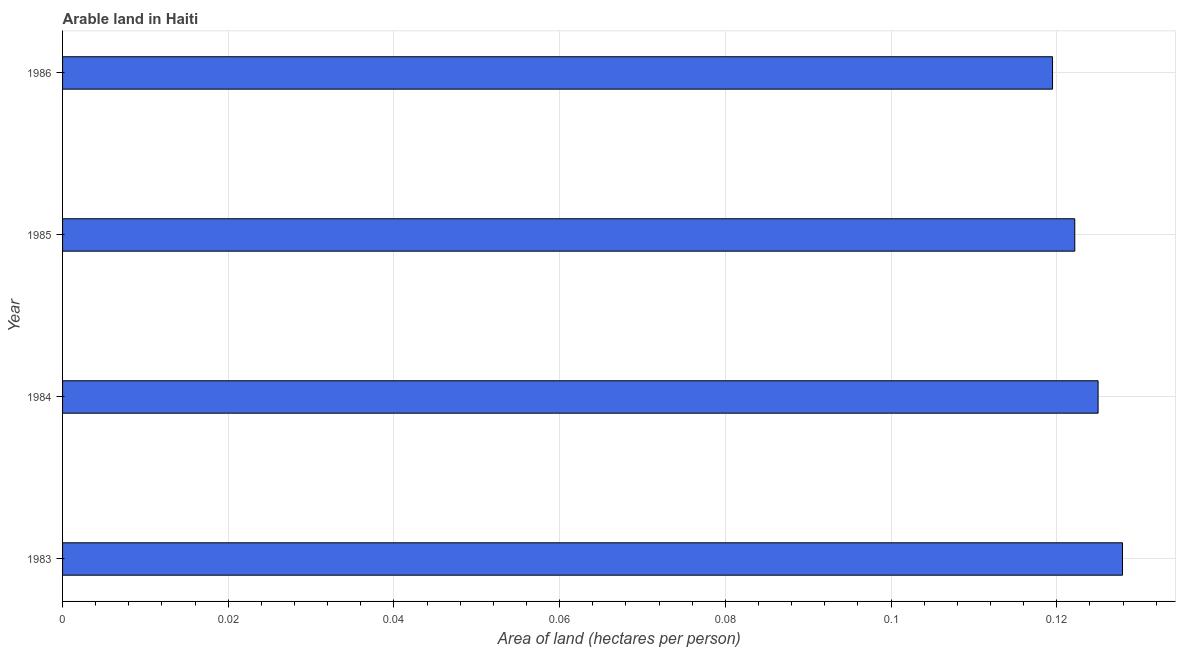What is the title of the graph?
Provide a succinct answer. Arable land in Haiti. What is the label or title of the X-axis?
Ensure brevity in your answer.  Area of land (hectares per person). What is the label or title of the Y-axis?
Offer a very short reply. Year. What is the area of arable land in 1983?
Provide a short and direct response. 0.13. Across all years, what is the maximum area of arable land?
Give a very brief answer. 0.13. Across all years, what is the minimum area of arable land?
Your response must be concise. 0.12. In which year was the area of arable land maximum?
Your answer should be compact. 1983. What is the sum of the area of arable land?
Ensure brevity in your answer.  0.49. What is the difference between the area of arable land in 1985 and 1986?
Provide a short and direct response. 0. What is the average area of arable land per year?
Offer a very short reply. 0.12. What is the median area of arable land?
Your response must be concise. 0.12. In how many years, is the area of arable land greater than 0.072 hectares per person?
Provide a short and direct response. 4. What is the ratio of the area of arable land in 1983 to that in 1985?
Your response must be concise. 1.05. Is the difference between the area of arable land in 1984 and 1985 greater than the difference between any two years?
Your answer should be very brief. No. What is the difference between the highest and the second highest area of arable land?
Your response must be concise. 0. In how many years, is the area of arable land greater than the average area of arable land taken over all years?
Provide a short and direct response. 2. How many bars are there?
Ensure brevity in your answer.  4. Are the values on the major ticks of X-axis written in scientific E-notation?
Make the answer very short. No. What is the Area of land (hectares per person) of 1983?
Offer a very short reply. 0.13. What is the Area of land (hectares per person) of 1984?
Offer a terse response. 0.12. What is the Area of land (hectares per person) of 1985?
Your response must be concise. 0.12. What is the Area of land (hectares per person) of 1986?
Your answer should be compact. 0.12. What is the difference between the Area of land (hectares per person) in 1983 and 1984?
Make the answer very short. 0. What is the difference between the Area of land (hectares per person) in 1983 and 1985?
Provide a short and direct response. 0.01. What is the difference between the Area of land (hectares per person) in 1983 and 1986?
Your answer should be compact. 0.01. What is the difference between the Area of land (hectares per person) in 1984 and 1985?
Your answer should be very brief. 0. What is the difference between the Area of land (hectares per person) in 1984 and 1986?
Make the answer very short. 0.01. What is the difference between the Area of land (hectares per person) in 1985 and 1986?
Keep it short and to the point. 0. What is the ratio of the Area of land (hectares per person) in 1983 to that in 1984?
Keep it short and to the point. 1.02. What is the ratio of the Area of land (hectares per person) in 1983 to that in 1985?
Keep it short and to the point. 1.05. What is the ratio of the Area of land (hectares per person) in 1983 to that in 1986?
Offer a very short reply. 1.07. What is the ratio of the Area of land (hectares per person) in 1984 to that in 1986?
Offer a terse response. 1.05. 